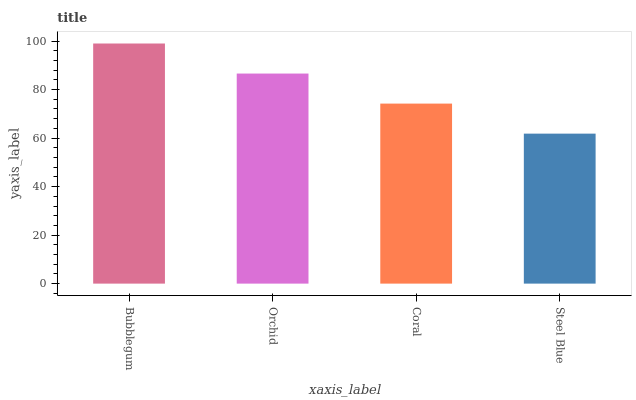Is Steel Blue the minimum?
Answer yes or no. Yes. Is Bubblegum the maximum?
Answer yes or no. Yes. Is Orchid the minimum?
Answer yes or no. No. Is Orchid the maximum?
Answer yes or no. No. Is Bubblegum greater than Orchid?
Answer yes or no. Yes. Is Orchid less than Bubblegum?
Answer yes or no. Yes. Is Orchid greater than Bubblegum?
Answer yes or no. No. Is Bubblegum less than Orchid?
Answer yes or no. No. Is Orchid the high median?
Answer yes or no. Yes. Is Coral the low median?
Answer yes or no. Yes. Is Coral the high median?
Answer yes or no. No. Is Bubblegum the low median?
Answer yes or no. No. 